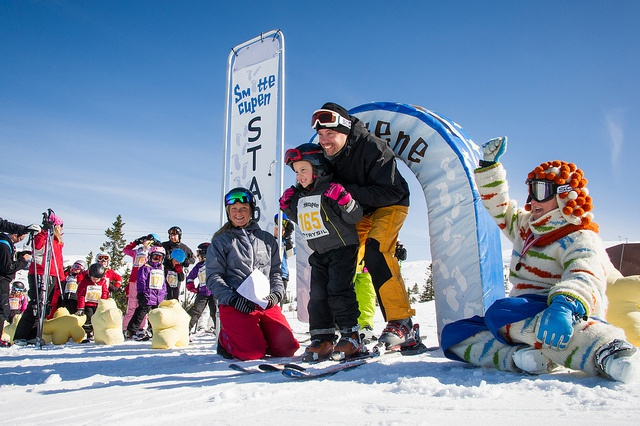Describe the objects in this image and their specific colors. I can see people in blue, darkgray, lightgray, navy, and gray tones, people in blue, black, gray, maroon, and lightgray tones, people in blue, maroon, black, navy, and gray tones, people in blue, black, olive, gray, and maroon tones, and people in blue, black, red, gray, and darkgray tones in this image. 